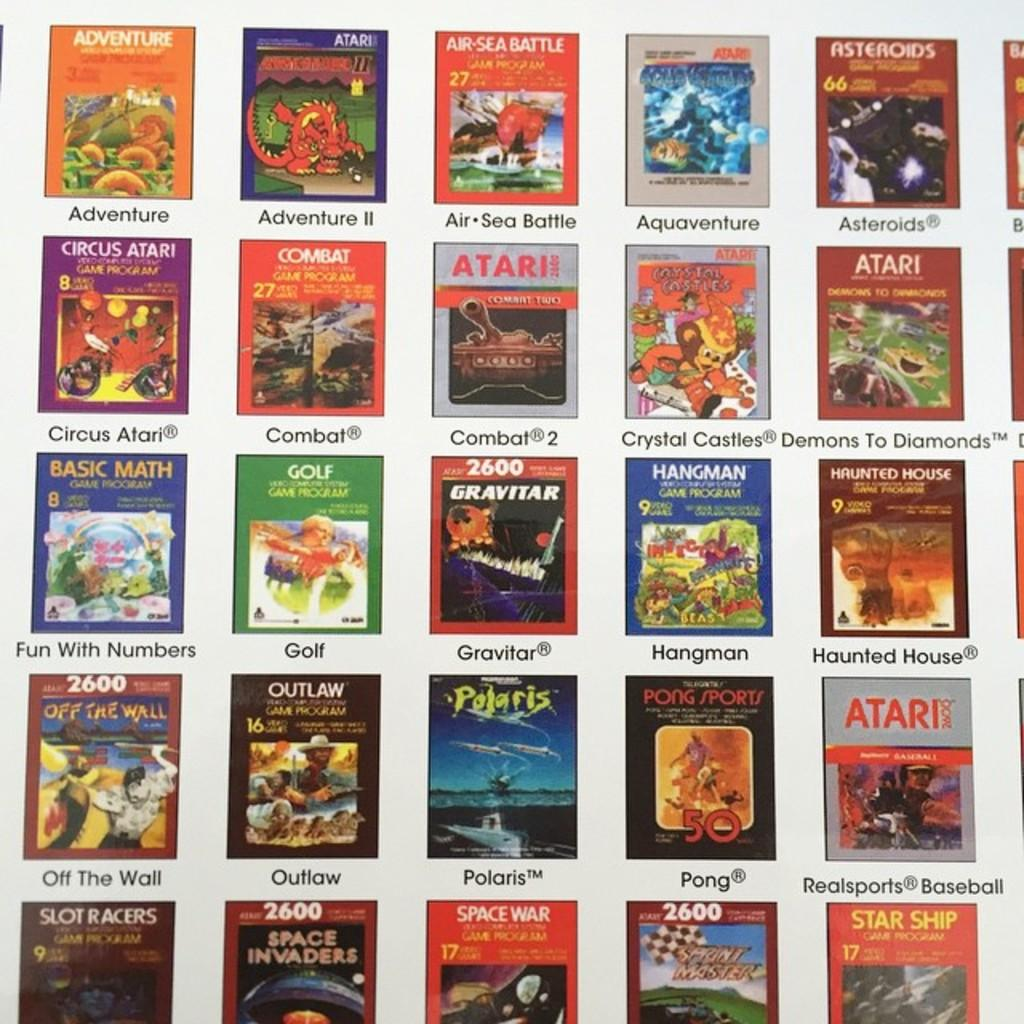<image>
Give a short and clear explanation of the subsequent image. A grid of video games includes several Atari games like Combat and Combat 2. 